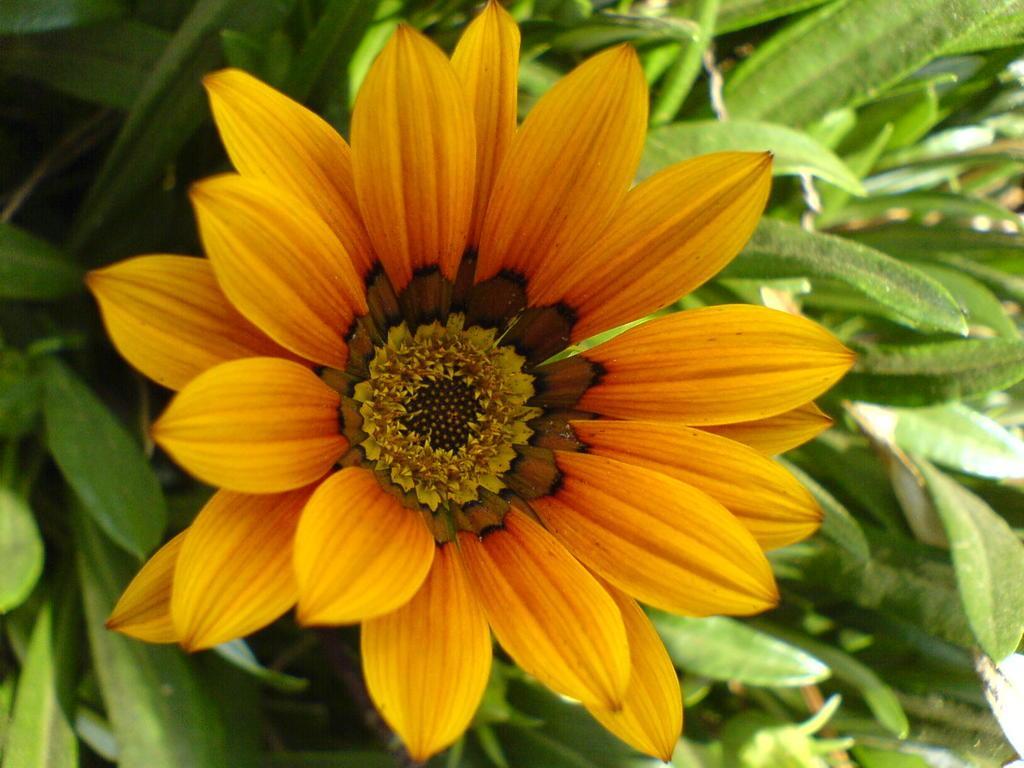Can you describe this image briefly? In this picture there is a flower on the plant and the flower is in orange color. 